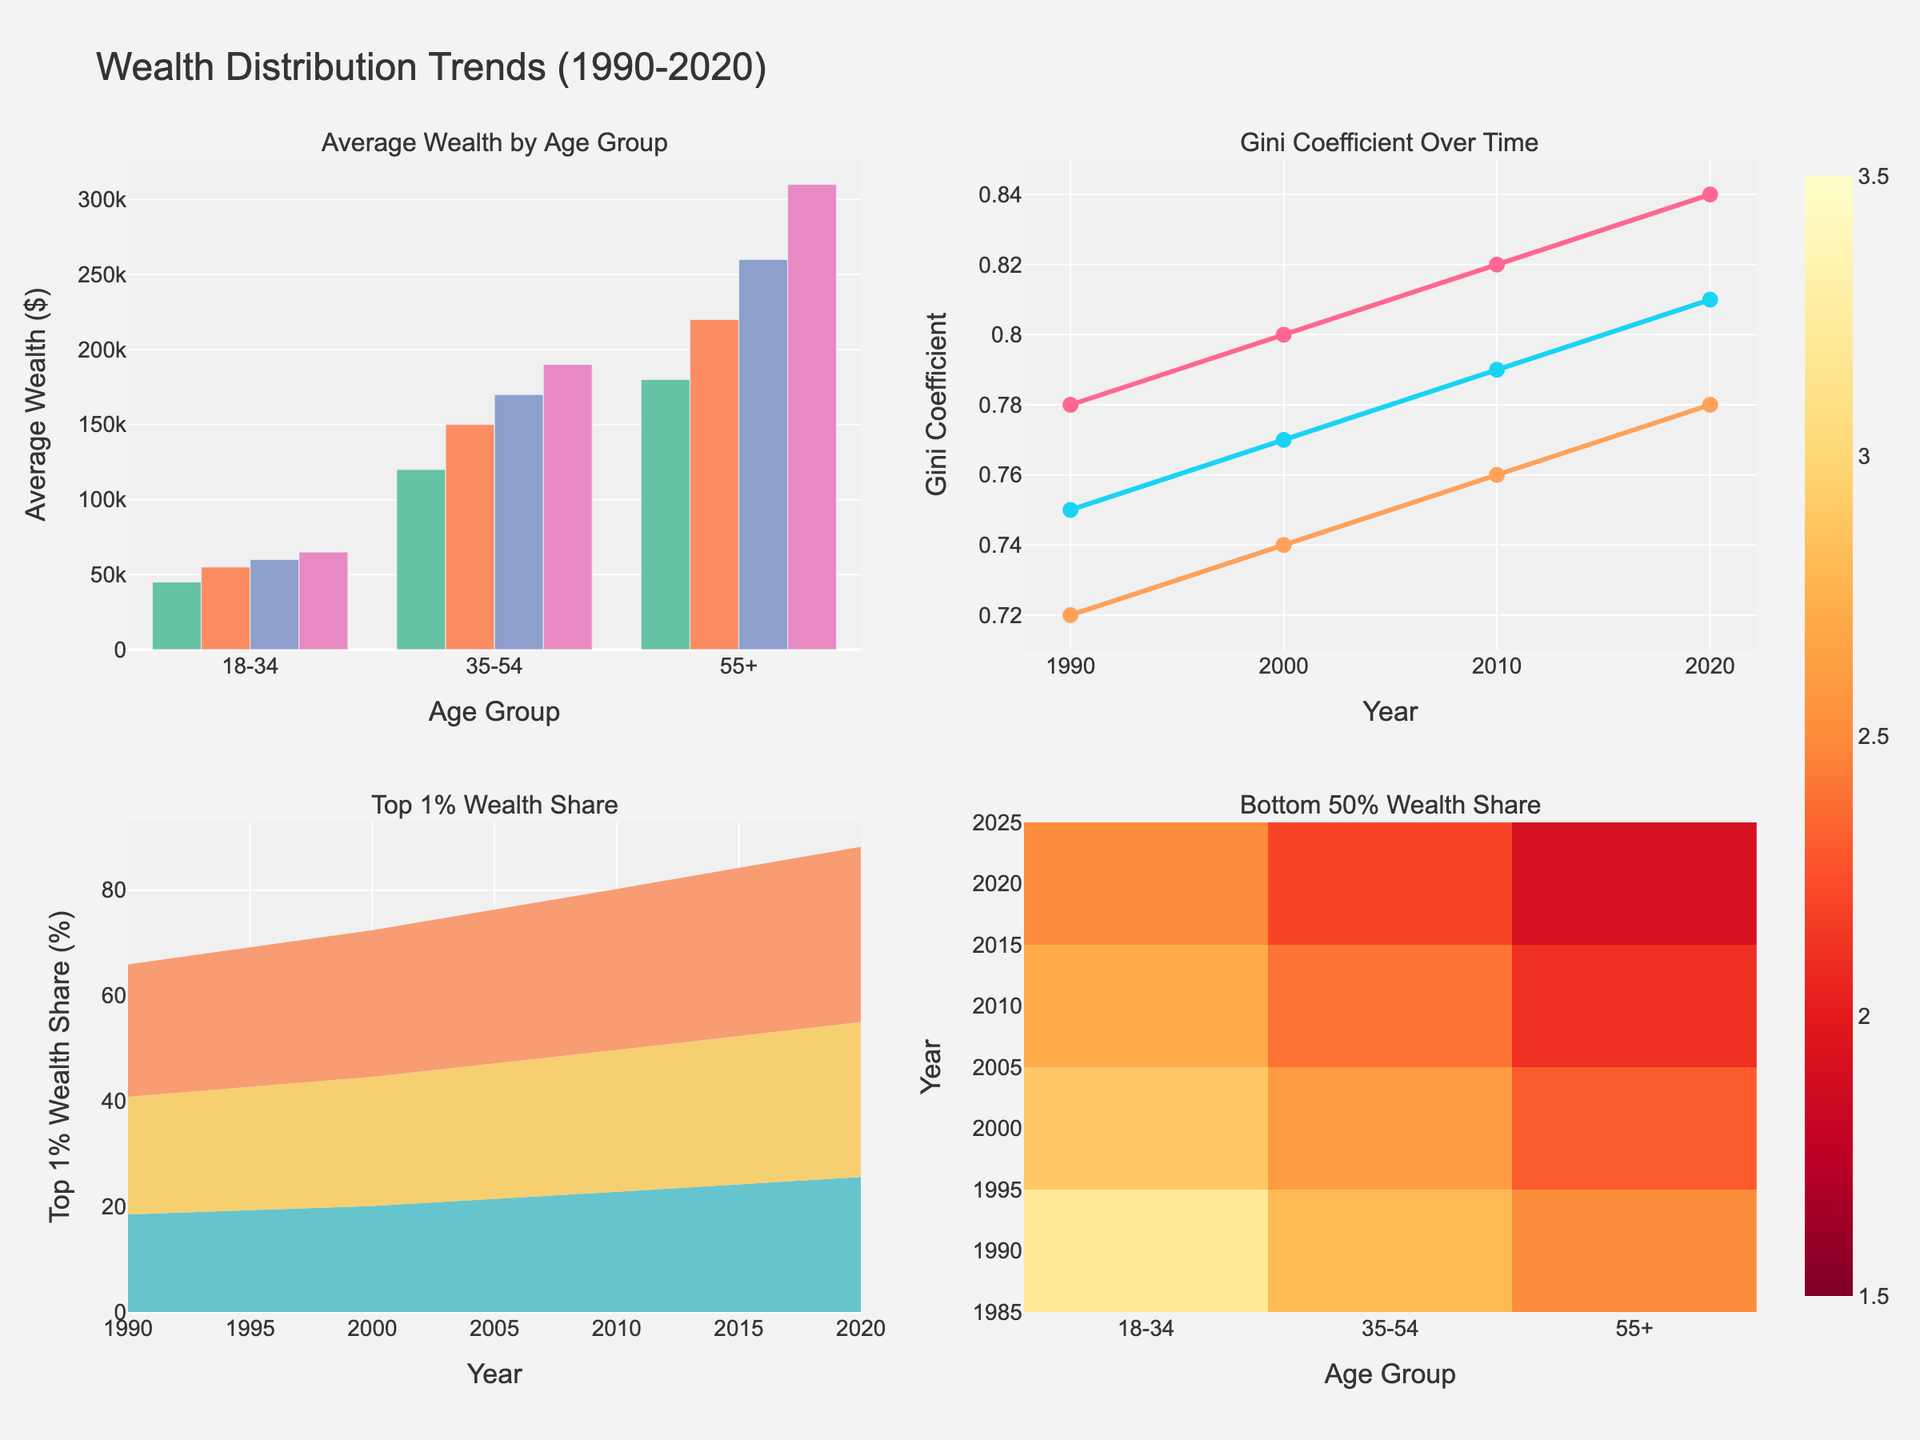What is the highest average wealth recorded for the age group 55+ over the years? Look at the "Average Wealth by Age Group" plot, identify the tallest bar for the age group 55+. The tallest bar for 55+ is in 2020 at $310,000.
Answer: $310,000 How did the Gini Coefficient for the age group 18-34 change from 1990 to 2020? Refer to the "Gini Coefficient Over Time" line chart, focus on the points representing the age group 18-34. In 1990, it was 0.72, and in 2020, it increased to 0.78.
Answer: Increased to 0.78 What is the change in the average wealth of age group 35-54 from 1990 to 2020? Locate the bars for 1990 and 2020 in the "Average Wealth by Age Group" plot for the age group 35-54. The average wealth increased from $120,000 in 1990 to $190,000 in 2020. The change is $190,000 - $120,000 = $70,000.
Answer: $70,000 Which age group has the highest Top 1% Wealth Share in 2010? Look at the "Top 1% Wealth Share" area chart for the year 2010, observe which group's area is highest for the year 2010. The highest is the age group 55+ with 30.5%.
Answer: 55+ Which age group showed the most considerable decrease in the Bottom 50% Wealth Share from 1990 to 2020? Refer to the "Bottom 50% Wealth Share" heatmap. Compare the change in values from 1990 to 2020 for each age group. The age group 55+ showed the most significant decrease from 2.5% (1990) to 1.9% (2020).
Answer: 55+ What general trend can you observe about the Top 1% Wealth Share for all age groups from 1990 to 2020? Analyze the "Top 1% Wealth Share" area chart, focusing on the overall patterns of the lines. The values for all age groups are rising over time, indicating an increasing trend.
Answer: Increasing trend Between which years did the average wealth of age group 18-34 show the least growth? Observe the "Average Wealth by Age Group" plot for the age group 18-34. The smallest increase happened between 2010 ($60,000) and 2020 ($65,000), a difference of $5,000.
Answer: 2010-2020 How does the average wealth of age group 55+ in 2000 compare to that of age group 35-54 in 2020? Locate the bars for 2000 (age group 55+) and 2020 (age group 35-54) in the "Average Wealth by Age Group" plot. In 2000, 55+ had $220,000, and in 2020, 35-54 had $190,000. Therefore, 55+ in 2000 had more average wealth than 35-54 in 2020 by $30,000.
Answer: $30,000 more 